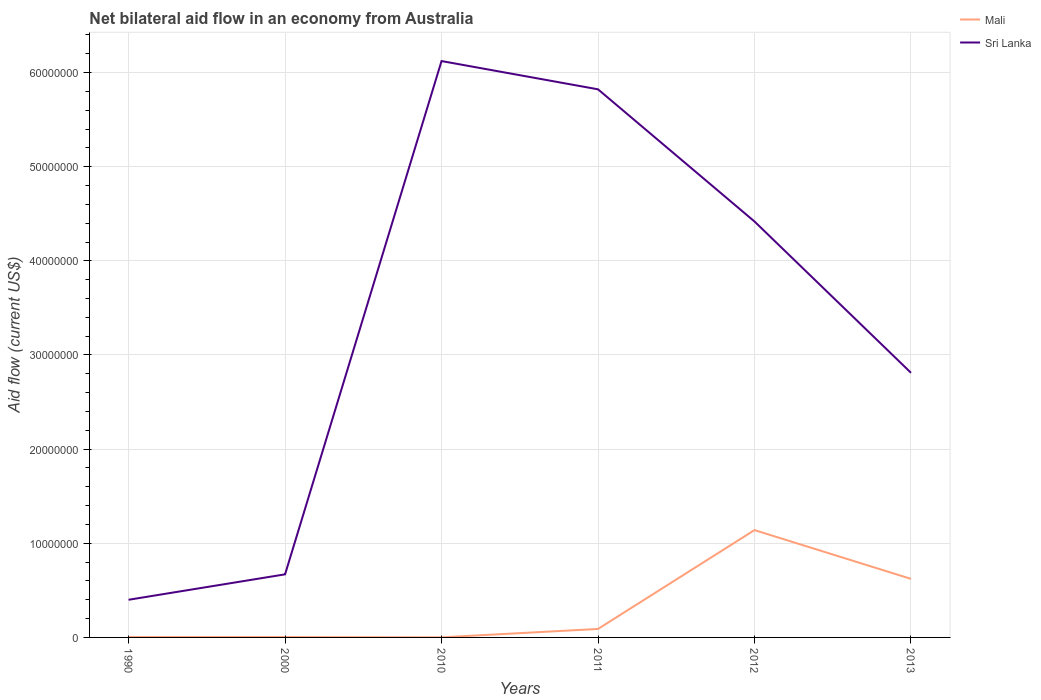In which year was the net bilateral aid flow in Sri Lanka maximum?
Provide a short and direct response. 1990. What is the total net bilateral aid flow in Sri Lanka in the graph?
Your response must be concise. 1.61e+07. What is the difference between the highest and the second highest net bilateral aid flow in Sri Lanka?
Provide a short and direct response. 5.72e+07. What is the difference between the highest and the lowest net bilateral aid flow in Mali?
Provide a succinct answer. 2. Is the net bilateral aid flow in Mali strictly greater than the net bilateral aid flow in Sri Lanka over the years?
Your response must be concise. Yes. How many years are there in the graph?
Provide a succinct answer. 6. What is the difference between two consecutive major ticks on the Y-axis?
Provide a succinct answer. 1.00e+07. Does the graph contain any zero values?
Provide a succinct answer. No. Does the graph contain grids?
Offer a very short reply. Yes. Where does the legend appear in the graph?
Offer a very short reply. Top right. What is the title of the graph?
Keep it short and to the point. Net bilateral aid flow in an economy from Australia. Does "Hong Kong" appear as one of the legend labels in the graph?
Offer a very short reply. No. What is the label or title of the Y-axis?
Provide a succinct answer. Aid flow (current US$). What is the Aid flow (current US$) of Mali in 1990?
Keep it short and to the point. 4.00e+04. What is the Aid flow (current US$) of Sri Lanka in 1990?
Keep it short and to the point. 4.00e+06. What is the Aid flow (current US$) of Sri Lanka in 2000?
Offer a terse response. 6.70e+06. What is the Aid flow (current US$) in Mali in 2010?
Ensure brevity in your answer.  10000. What is the Aid flow (current US$) in Sri Lanka in 2010?
Your answer should be very brief. 6.12e+07. What is the Aid flow (current US$) of Sri Lanka in 2011?
Provide a short and direct response. 5.82e+07. What is the Aid flow (current US$) in Mali in 2012?
Your answer should be very brief. 1.14e+07. What is the Aid flow (current US$) in Sri Lanka in 2012?
Offer a very short reply. 4.42e+07. What is the Aid flow (current US$) of Mali in 2013?
Ensure brevity in your answer.  6.22e+06. What is the Aid flow (current US$) of Sri Lanka in 2013?
Ensure brevity in your answer.  2.81e+07. Across all years, what is the maximum Aid flow (current US$) in Mali?
Ensure brevity in your answer.  1.14e+07. Across all years, what is the maximum Aid flow (current US$) in Sri Lanka?
Give a very brief answer. 6.12e+07. What is the total Aid flow (current US$) in Mali in the graph?
Offer a terse response. 1.86e+07. What is the total Aid flow (current US$) in Sri Lanka in the graph?
Offer a very short reply. 2.02e+08. What is the difference between the Aid flow (current US$) in Mali in 1990 and that in 2000?
Offer a very short reply. 0. What is the difference between the Aid flow (current US$) in Sri Lanka in 1990 and that in 2000?
Provide a short and direct response. -2.70e+06. What is the difference between the Aid flow (current US$) of Sri Lanka in 1990 and that in 2010?
Your response must be concise. -5.72e+07. What is the difference between the Aid flow (current US$) in Mali in 1990 and that in 2011?
Your answer should be compact. -8.60e+05. What is the difference between the Aid flow (current US$) in Sri Lanka in 1990 and that in 2011?
Your answer should be very brief. -5.42e+07. What is the difference between the Aid flow (current US$) of Mali in 1990 and that in 2012?
Give a very brief answer. -1.14e+07. What is the difference between the Aid flow (current US$) of Sri Lanka in 1990 and that in 2012?
Provide a succinct answer. -4.02e+07. What is the difference between the Aid flow (current US$) of Mali in 1990 and that in 2013?
Ensure brevity in your answer.  -6.18e+06. What is the difference between the Aid flow (current US$) in Sri Lanka in 1990 and that in 2013?
Ensure brevity in your answer.  -2.41e+07. What is the difference between the Aid flow (current US$) of Mali in 2000 and that in 2010?
Keep it short and to the point. 3.00e+04. What is the difference between the Aid flow (current US$) in Sri Lanka in 2000 and that in 2010?
Offer a terse response. -5.45e+07. What is the difference between the Aid flow (current US$) of Mali in 2000 and that in 2011?
Give a very brief answer. -8.60e+05. What is the difference between the Aid flow (current US$) in Sri Lanka in 2000 and that in 2011?
Give a very brief answer. -5.15e+07. What is the difference between the Aid flow (current US$) of Mali in 2000 and that in 2012?
Offer a terse response. -1.14e+07. What is the difference between the Aid flow (current US$) of Sri Lanka in 2000 and that in 2012?
Offer a very short reply. -3.75e+07. What is the difference between the Aid flow (current US$) in Mali in 2000 and that in 2013?
Ensure brevity in your answer.  -6.18e+06. What is the difference between the Aid flow (current US$) of Sri Lanka in 2000 and that in 2013?
Your answer should be compact. -2.14e+07. What is the difference between the Aid flow (current US$) in Mali in 2010 and that in 2011?
Give a very brief answer. -8.90e+05. What is the difference between the Aid flow (current US$) of Mali in 2010 and that in 2012?
Offer a very short reply. -1.14e+07. What is the difference between the Aid flow (current US$) in Sri Lanka in 2010 and that in 2012?
Offer a terse response. 1.70e+07. What is the difference between the Aid flow (current US$) in Mali in 2010 and that in 2013?
Provide a succinct answer. -6.21e+06. What is the difference between the Aid flow (current US$) of Sri Lanka in 2010 and that in 2013?
Make the answer very short. 3.31e+07. What is the difference between the Aid flow (current US$) in Mali in 2011 and that in 2012?
Provide a succinct answer. -1.05e+07. What is the difference between the Aid flow (current US$) in Sri Lanka in 2011 and that in 2012?
Give a very brief answer. 1.40e+07. What is the difference between the Aid flow (current US$) of Mali in 2011 and that in 2013?
Offer a very short reply. -5.32e+06. What is the difference between the Aid flow (current US$) of Sri Lanka in 2011 and that in 2013?
Your answer should be very brief. 3.01e+07. What is the difference between the Aid flow (current US$) in Mali in 2012 and that in 2013?
Your answer should be very brief. 5.18e+06. What is the difference between the Aid flow (current US$) in Sri Lanka in 2012 and that in 2013?
Provide a short and direct response. 1.61e+07. What is the difference between the Aid flow (current US$) in Mali in 1990 and the Aid flow (current US$) in Sri Lanka in 2000?
Your answer should be compact. -6.66e+06. What is the difference between the Aid flow (current US$) in Mali in 1990 and the Aid flow (current US$) in Sri Lanka in 2010?
Ensure brevity in your answer.  -6.12e+07. What is the difference between the Aid flow (current US$) of Mali in 1990 and the Aid flow (current US$) of Sri Lanka in 2011?
Make the answer very short. -5.82e+07. What is the difference between the Aid flow (current US$) in Mali in 1990 and the Aid flow (current US$) in Sri Lanka in 2012?
Ensure brevity in your answer.  -4.41e+07. What is the difference between the Aid flow (current US$) in Mali in 1990 and the Aid flow (current US$) in Sri Lanka in 2013?
Provide a succinct answer. -2.81e+07. What is the difference between the Aid flow (current US$) of Mali in 2000 and the Aid flow (current US$) of Sri Lanka in 2010?
Keep it short and to the point. -6.12e+07. What is the difference between the Aid flow (current US$) of Mali in 2000 and the Aid flow (current US$) of Sri Lanka in 2011?
Offer a very short reply. -5.82e+07. What is the difference between the Aid flow (current US$) of Mali in 2000 and the Aid flow (current US$) of Sri Lanka in 2012?
Provide a succinct answer. -4.41e+07. What is the difference between the Aid flow (current US$) in Mali in 2000 and the Aid flow (current US$) in Sri Lanka in 2013?
Make the answer very short. -2.81e+07. What is the difference between the Aid flow (current US$) of Mali in 2010 and the Aid flow (current US$) of Sri Lanka in 2011?
Your answer should be compact. -5.82e+07. What is the difference between the Aid flow (current US$) of Mali in 2010 and the Aid flow (current US$) of Sri Lanka in 2012?
Offer a terse response. -4.42e+07. What is the difference between the Aid flow (current US$) in Mali in 2010 and the Aid flow (current US$) in Sri Lanka in 2013?
Your answer should be compact. -2.81e+07. What is the difference between the Aid flow (current US$) of Mali in 2011 and the Aid flow (current US$) of Sri Lanka in 2012?
Ensure brevity in your answer.  -4.33e+07. What is the difference between the Aid flow (current US$) of Mali in 2011 and the Aid flow (current US$) of Sri Lanka in 2013?
Your answer should be very brief. -2.72e+07. What is the difference between the Aid flow (current US$) of Mali in 2012 and the Aid flow (current US$) of Sri Lanka in 2013?
Your answer should be compact. -1.67e+07. What is the average Aid flow (current US$) of Mali per year?
Make the answer very short. 3.10e+06. What is the average Aid flow (current US$) of Sri Lanka per year?
Provide a succinct answer. 3.37e+07. In the year 1990, what is the difference between the Aid flow (current US$) of Mali and Aid flow (current US$) of Sri Lanka?
Keep it short and to the point. -3.96e+06. In the year 2000, what is the difference between the Aid flow (current US$) in Mali and Aid flow (current US$) in Sri Lanka?
Offer a very short reply. -6.66e+06. In the year 2010, what is the difference between the Aid flow (current US$) of Mali and Aid flow (current US$) of Sri Lanka?
Ensure brevity in your answer.  -6.12e+07. In the year 2011, what is the difference between the Aid flow (current US$) of Mali and Aid flow (current US$) of Sri Lanka?
Your response must be concise. -5.73e+07. In the year 2012, what is the difference between the Aid flow (current US$) in Mali and Aid flow (current US$) in Sri Lanka?
Your answer should be compact. -3.28e+07. In the year 2013, what is the difference between the Aid flow (current US$) in Mali and Aid flow (current US$) in Sri Lanka?
Offer a terse response. -2.19e+07. What is the ratio of the Aid flow (current US$) in Sri Lanka in 1990 to that in 2000?
Ensure brevity in your answer.  0.6. What is the ratio of the Aid flow (current US$) of Mali in 1990 to that in 2010?
Provide a succinct answer. 4. What is the ratio of the Aid flow (current US$) in Sri Lanka in 1990 to that in 2010?
Give a very brief answer. 0.07. What is the ratio of the Aid flow (current US$) in Mali in 1990 to that in 2011?
Ensure brevity in your answer.  0.04. What is the ratio of the Aid flow (current US$) of Sri Lanka in 1990 to that in 2011?
Your response must be concise. 0.07. What is the ratio of the Aid flow (current US$) of Mali in 1990 to that in 2012?
Provide a succinct answer. 0. What is the ratio of the Aid flow (current US$) in Sri Lanka in 1990 to that in 2012?
Keep it short and to the point. 0.09. What is the ratio of the Aid flow (current US$) of Mali in 1990 to that in 2013?
Your answer should be compact. 0.01. What is the ratio of the Aid flow (current US$) in Sri Lanka in 1990 to that in 2013?
Ensure brevity in your answer.  0.14. What is the ratio of the Aid flow (current US$) in Mali in 2000 to that in 2010?
Provide a short and direct response. 4. What is the ratio of the Aid flow (current US$) in Sri Lanka in 2000 to that in 2010?
Keep it short and to the point. 0.11. What is the ratio of the Aid flow (current US$) in Mali in 2000 to that in 2011?
Your response must be concise. 0.04. What is the ratio of the Aid flow (current US$) of Sri Lanka in 2000 to that in 2011?
Your answer should be very brief. 0.12. What is the ratio of the Aid flow (current US$) of Mali in 2000 to that in 2012?
Make the answer very short. 0. What is the ratio of the Aid flow (current US$) in Sri Lanka in 2000 to that in 2012?
Your response must be concise. 0.15. What is the ratio of the Aid flow (current US$) of Mali in 2000 to that in 2013?
Your answer should be very brief. 0.01. What is the ratio of the Aid flow (current US$) in Sri Lanka in 2000 to that in 2013?
Make the answer very short. 0.24. What is the ratio of the Aid flow (current US$) of Mali in 2010 to that in 2011?
Make the answer very short. 0.01. What is the ratio of the Aid flow (current US$) of Sri Lanka in 2010 to that in 2011?
Ensure brevity in your answer.  1.05. What is the ratio of the Aid flow (current US$) of Mali in 2010 to that in 2012?
Offer a terse response. 0. What is the ratio of the Aid flow (current US$) in Sri Lanka in 2010 to that in 2012?
Your answer should be very brief. 1.39. What is the ratio of the Aid flow (current US$) in Mali in 2010 to that in 2013?
Provide a succinct answer. 0. What is the ratio of the Aid flow (current US$) of Sri Lanka in 2010 to that in 2013?
Offer a very short reply. 2.18. What is the ratio of the Aid flow (current US$) in Mali in 2011 to that in 2012?
Your answer should be very brief. 0.08. What is the ratio of the Aid flow (current US$) in Sri Lanka in 2011 to that in 2012?
Your answer should be very brief. 1.32. What is the ratio of the Aid flow (current US$) in Mali in 2011 to that in 2013?
Provide a succinct answer. 0.14. What is the ratio of the Aid flow (current US$) in Sri Lanka in 2011 to that in 2013?
Make the answer very short. 2.07. What is the ratio of the Aid flow (current US$) of Mali in 2012 to that in 2013?
Your response must be concise. 1.83. What is the ratio of the Aid flow (current US$) in Sri Lanka in 2012 to that in 2013?
Offer a terse response. 1.57. What is the difference between the highest and the second highest Aid flow (current US$) of Mali?
Give a very brief answer. 5.18e+06. What is the difference between the highest and the lowest Aid flow (current US$) of Mali?
Your answer should be very brief. 1.14e+07. What is the difference between the highest and the lowest Aid flow (current US$) of Sri Lanka?
Make the answer very short. 5.72e+07. 